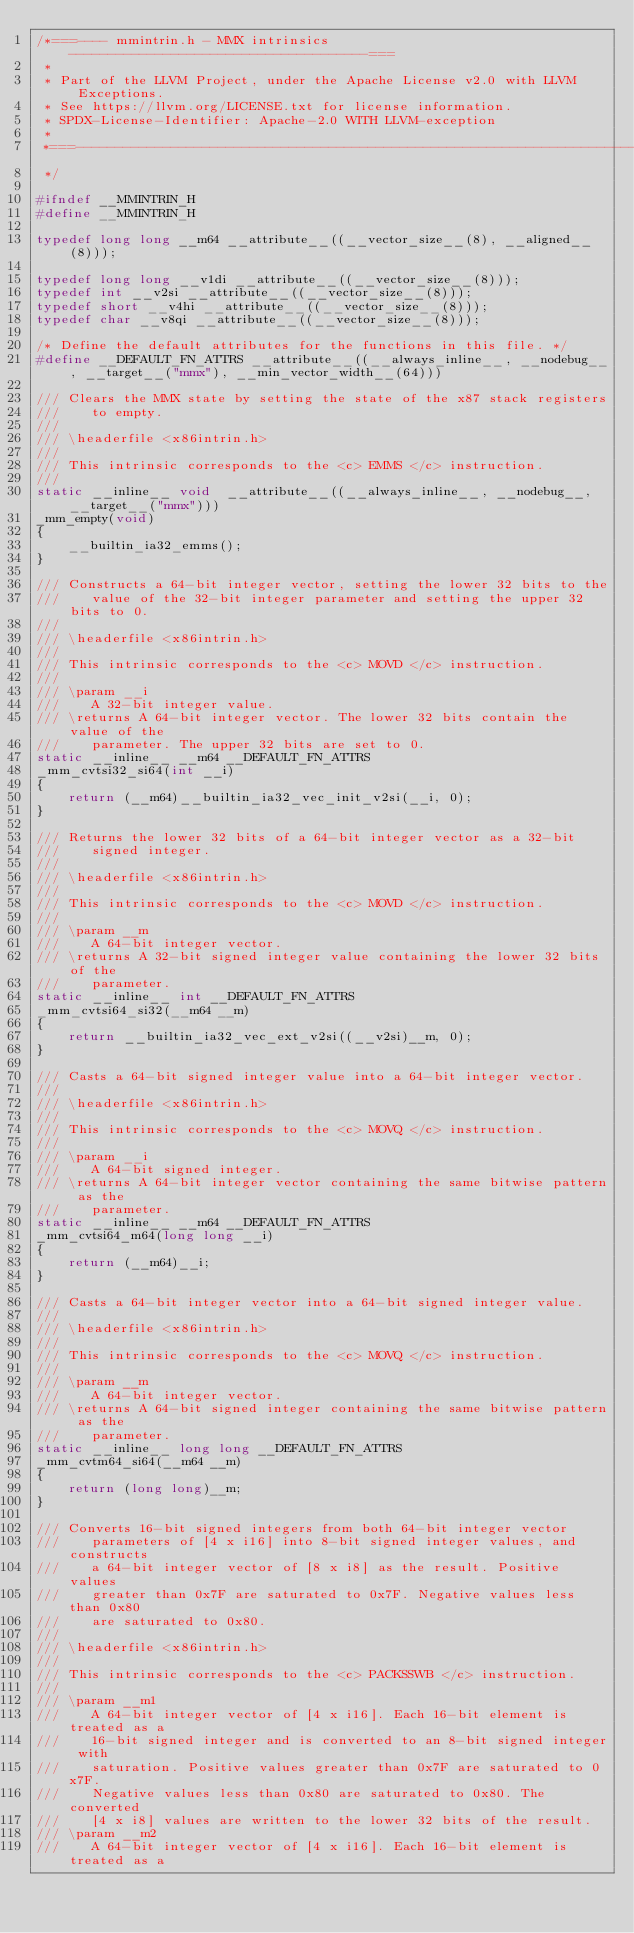Convert code to text. <code><loc_0><loc_0><loc_500><loc_500><_C_>/*===---- mmintrin.h - MMX intrinsics --------------------------------------===
 *
 * Part of the LLVM Project, under the Apache License v2.0 with LLVM Exceptions.
 * See https://llvm.org/LICENSE.txt for license information.
 * SPDX-License-Identifier: Apache-2.0 WITH LLVM-exception
 *
 *===-----------------------------------------------------------------------===
 */

#ifndef __MMINTRIN_H
#define __MMINTRIN_H

typedef long long __m64 __attribute__((__vector_size__(8), __aligned__(8)));

typedef long long __v1di __attribute__((__vector_size__(8)));
typedef int __v2si __attribute__((__vector_size__(8)));
typedef short __v4hi __attribute__((__vector_size__(8)));
typedef char __v8qi __attribute__((__vector_size__(8)));

/* Define the default attributes for the functions in this file. */
#define __DEFAULT_FN_ATTRS __attribute__((__always_inline__, __nodebug__, __target__("mmx"), __min_vector_width__(64)))

/// Clears the MMX state by setting the state of the x87 stack registers
///    to empty.
///
/// \headerfile <x86intrin.h>
///
/// This intrinsic corresponds to the <c> EMMS </c> instruction.
///
static __inline__ void  __attribute__((__always_inline__, __nodebug__, __target__("mmx")))
_mm_empty(void)
{
    __builtin_ia32_emms();
}

/// Constructs a 64-bit integer vector, setting the lower 32 bits to the
///    value of the 32-bit integer parameter and setting the upper 32 bits to 0.
///
/// \headerfile <x86intrin.h>
///
/// This intrinsic corresponds to the <c> MOVD </c> instruction.
///
/// \param __i
///    A 32-bit integer value.
/// \returns A 64-bit integer vector. The lower 32 bits contain the value of the
///    parameter. The upper 32 bits are set to 0.
static __inline__ __m64 __DEFAULT_FN_ATTRS
_mm_cvtsi32_si64(int __i)
{
    return (__m64)__builtin_ia32_vec_init_v2si(__i, 0);
}

/// Returns the lower 32 bits of a 64-bit integer vector as a 32-bit
///    signed integer.
///
/// \headerfile <x86intrin.h>
///
/// This intrinsic corresponds to the <c> MOVD </c> instruction.
///
/// \param __m
///    A 64-bit integer vector.
/// \returns A 32-bit signed integer value containing the lower 32 bits of the
///    parameter.
static __inline__ int __DEFAULT_FN_ATTRS
_mm_cvtsi64_si32(__m64 __m)
{
    return __builtin_ia32_vec_ext_v2si((__v2si)__m, 0);
}

/// Casts a 64-bit signed integer value into a 64-bit integer vector.
///
/// \headerfile <x86intrin.h>
///
/// This intrinsic corresponds to the <c> MOVQ </c> instruction.
///
/// \param __i
///    A 64-bit signed integer.
/// \returns A 64-bit integer vector containing the same bitwise pattern as the
///    parameter.
static __inline__ __m64 __DEFAULT_FN_ATTRS
_mm_cvtsi64_m64(long long __i)
{
    return (__m64)__i;
}

/// Casts a 64-bit integer vector into a 64-bit signed integer value.
///
/// \headerfile <x86intrin.h>
///
/// This intrinsic corresponds to the <c> MOVQ </c> instruction.
///
/// \param __m
///    A 64-bit integer vector.
/// \returns A 64-bit signed integer containing the same bitwise pattern as the
///    parameter.
static __inline__ long long __DEFAULT_FN_ATTRS
_mm_cvtm64_si64(__m64 __m)
{
    return (long long)__m;
}

/// Converts 16-bit signed integers from both 64-bit integer vector
///    parameters of [4 x i16] into 8-bit signed integer values, and constructs
///    a 64-bit integer vector of [8 x i8] as the result. Positive values
///    greater than 0x7F are saturated to 0x7F. Negative values less than 0x80
///    are saturated to 0x80.
///
/// \headerfile <x86intrin.h>
///
/// This intrinsic corresponds to the <c> PACKSSWB </c> instruction.
///
/// \param __m1
///    A 64-bit integer vector of [4 x i16]. Each 16-bit element is treated as a
///    16-bit signed integer and is converted to an 8-bit signed integer with
///    saturation. Positive values greater than 0x7F are saturated to 0x7F.
///    Negative values less than 0x80 are saturated to 0x80. The converted
///    [4 x i8] values are written to the lower 32 bits of the result.
/// \param __m2
///    A 64-bit integer vector of [4 x i16]. Each 16-bit element is treated as a</code> 